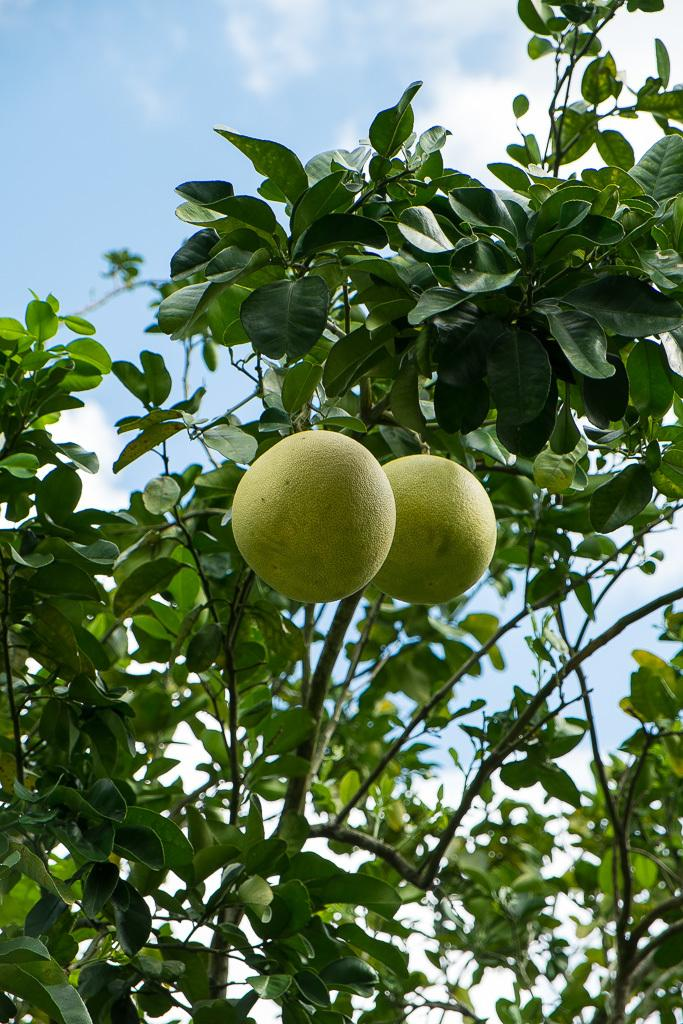What type of fruit can be seen on the tree in the image? There are lemons on a tree in the image. What can be seen in the background of the image? The sky is visible in the background of the image. What type of oil can be seen dripping from the lemons in the image? There is no oil present in the image, and the lemons are not dripping anything. 